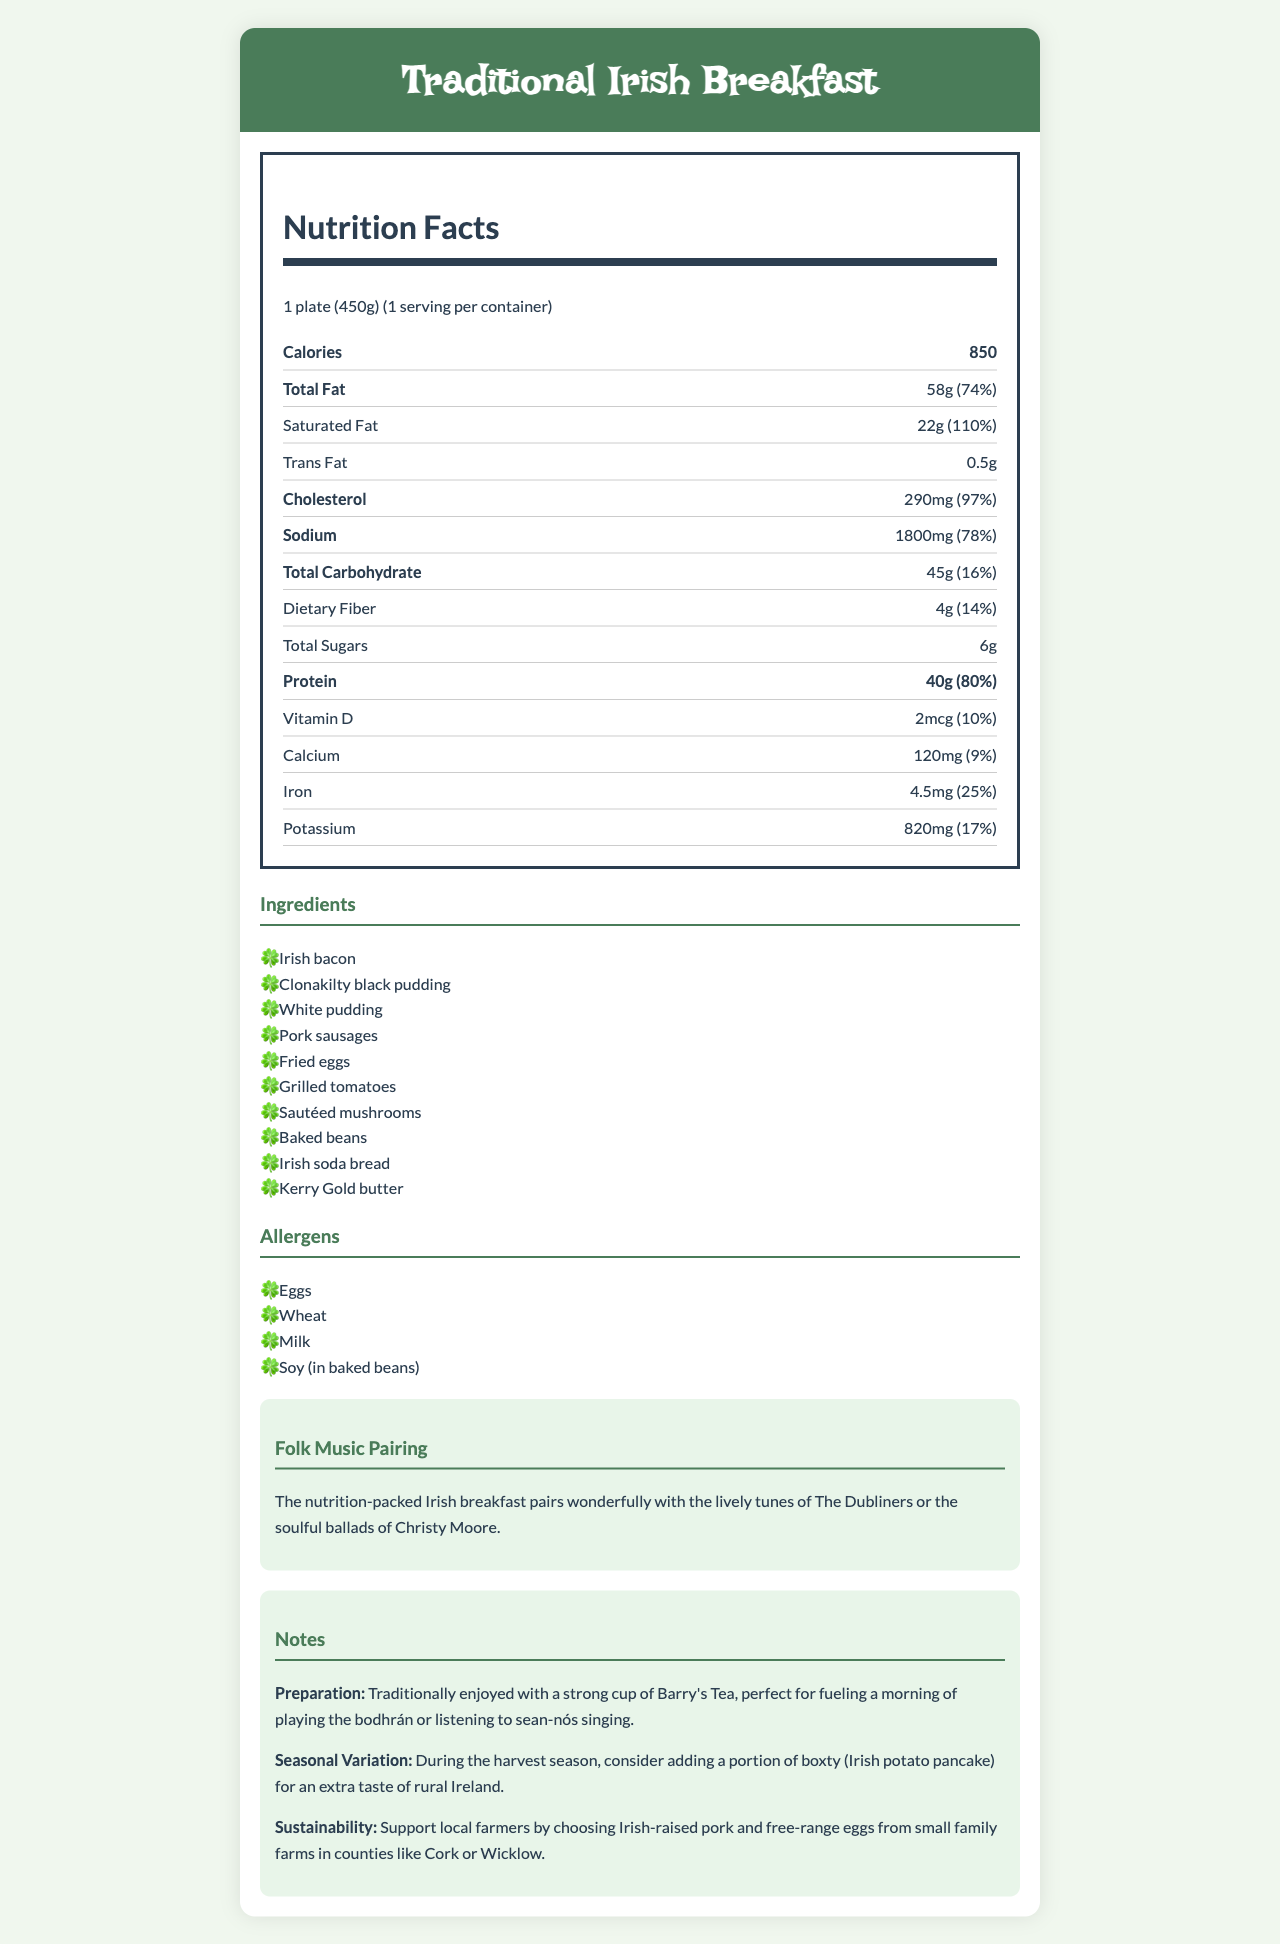what is the serving size of the Traditional Irish Breakfast? The serving size is explicitly mentioned as 1 plate (450g) in the document.
Answer: 1 plate (450g) how many grams of protein does one plate of Traditional Irish Breakfast contain? The document states the amount of protein per serving as 40g.
Answer: 40g what is the percentage of daily value for total fat in one serving of the Traditional Irish Breakfast? The document lists the daily value percentage for total fat as 74%.
Answer: 74% how much saturated fat is in a Traditional Irish Breakfast? The document indicates that there are 22g of saturated fat in one serving.
Answer: 22g what are the main ingredients used in a Traditional Irish Breakfast? The document provides a list of all the main ingredients used in the breakfast.
Answer: Irish bacon, Clonakilty black pudding, White pudding, Pork sausages, Fried eggs, Grilled tomatoes, Sautéed mushrooms, Baked beans, Irish soda bread, Kerry Gold butter which food item has a daily value percentage of 110%? A. Total Fat B. Protein C. Saturated Fat D. Cholesterol The document specifies that saturated fat has a daily value of 110%, whereas total fat has 74%, protein has 80%, and cholesterol is 97%.
Answer: C. Saturated Fat how many calories are in one plate of the Traditional Irish Breakfast? A. 500 B. 680 C. 850 D. 950 The document mentions that one serving contains 850 calories.
Answer: C. 850 does the Traditional Irish Breakfast contain any trans fat? The document specifies that it contains 0.5g of trans fat.
Answer: Yes is there more total fat or protein in one serving of the Traditional Irish Breakfast? The document indicates that there are 58g of total fat compared to 40g of protein.
Answer: Total fat what is a suitable folk music pairing for the Traditional Irish Breakfast? The document mentions a folk music pairing with the lively tunes of The Dubliners or the soulful ballads of Christy Moore.
Answer: The lively tunes of The Dubliners or the soulful ballads of Christy Moore how is a Traditional Irish Breakfast recommended to be enjoyed according to the document? The document suggests that the breakfast is traditionally enjoyed with a strong cup of Barry's Tea, ideal for a morning of musical activities.
Answer: With a strong cup of Barry's Tea, perfect for fueling a morning of playing the bodhrán or listening to sean-nós singing is the sustainability information provided in the document? The document mentions supporting local farmers by choosing Irish-raised pork and free-range eggs from small family farms.
Answer: Yes what should be added during the harvest season for a Traditional Irish Breakfast, according to the document? The document suggests adding boxty during the harvest season for an extra taste of rural Ireland.
Answer: Boxty (Irish potato pancake) describe the entire document The document not only details the nutritional content of the breakfast but also enriches the cultural context by suggesting folk music pairings and sustainable practices, along with preparation and seasonal variation tips.
Answer: The document provides comprehensive nutritional information for a Traditional Irish Breakfast, including serving size, calories, and detailed breakdowns of fat, protein, and other nutrients. It lists the ingredients, allergens, and suggests pairing the meal with Irish folk music. Additionally, it includes preparation notes, seasonal variations, and sustainability information. how many vitamins and minerals are listed in the document? The document lists four main vitamins and minerals: Vitamin D, Calcium, Iron, and Potassium.
Answer: Six: Vitamin D, Calcium, Iron, Potassium what is the daily value percentage for cholesterol in the Traditional Irish Breakfast? The document lists the daily value percentage for cholesterol as 97%.
Answer: 97% what is the daily value percentage of dietary fiber in one serving? The document specifies that dietary fiber has a daily value percentage of 14%.
Answer: 14% how many servings are there per container of the Traditional Irish Breakfast? The document indicates that there is 1 serving per container.
Answer: 1 what are the food allergens listed in the Traditional Irish Breakfast? The document lists the allergens as Eggs, Wheat, Milk, and Soy (in baked beans).
Answer: Eggs, Wheat, Milk, Soy (in baked beans) which counties are suggested for sourcing ingredients to support local farmers? The document mentions counties like Cork or Wicklow for sourcing Irish-raised pork and free-range eggs.
Answer: Cork or Wicklow what is the traditional accompaniment to the breakfast that complements musical activities like playing the bodhrán or listening to sean-nós singing? The document notes that the breakfast is traditionally enjoyed with a strong cup of Barry's Tea, perfect for fueling musical activities.
Answer: A strong cup of Barry's Tea how many ingredients are listed in the Traditional Irish Breakfast? The document lists ten main ingredients used in the breakfast.
Answer: Ten 